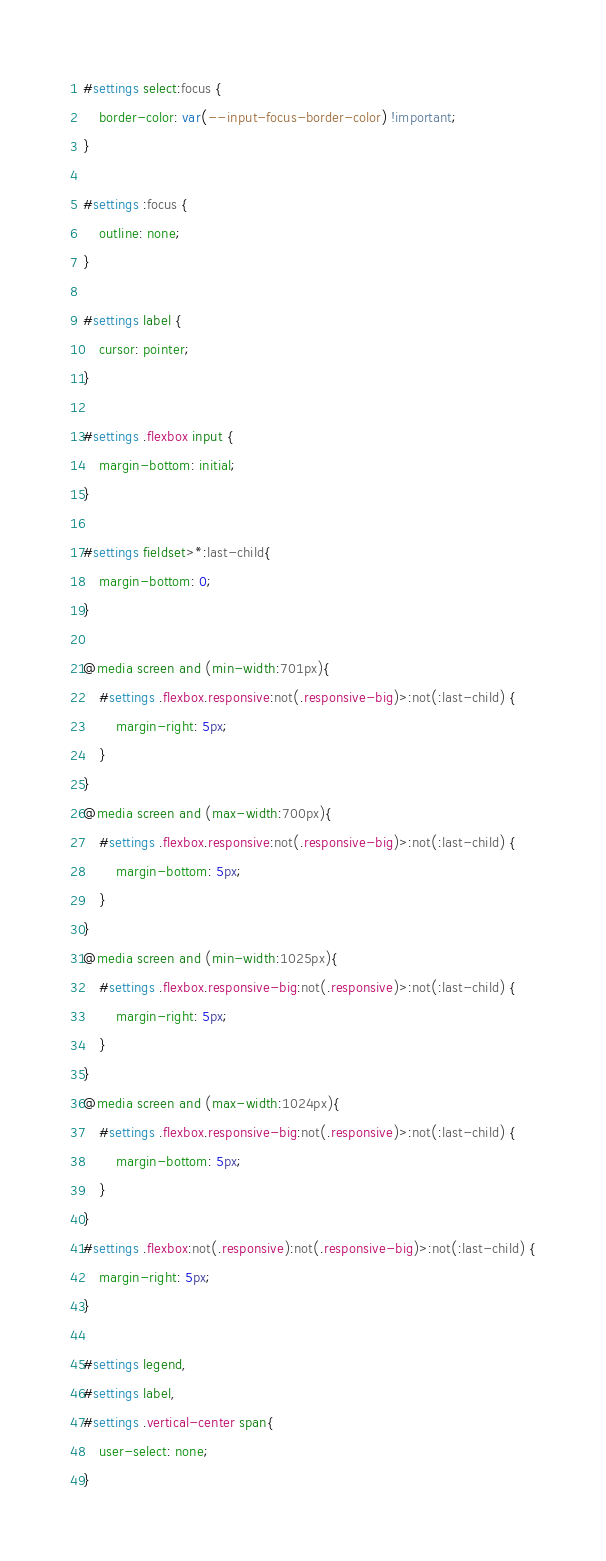Convert code to text. <code><loc_0><loc_0><loc_500><loc_500><_CSS_>#settings select:focus {
    border-color: var(--input-focus-border-color) !important;
}

#settings :focus {
    outline: none;
}

#settings label {
    cursor: pointer;
}

#settings .flexbox input {
    margin-bottom: initial;
}

#settings fieldset>*:last-child{
    margin-bottom: 0;
}

@media screen and (min-width:701px){
    #settings .flexbox.responsive:not(.responsive-big)>:not(:last-child) {
        margin-right: 5px;
    }
}
@media screen and (max-width:700px){
    #settings .flexbox.responsive:not(.responsive-big)>:not(:last-child) {
        margin-bottom: 5px;
    }
}
@media screen and (min-width:1025px){
    #settings .flexbox.responsive-big:not(.responsive)>:not(:last-child) {
        margin-right: 5px;
    }
}
@media screen and (max-width:1024px){
    #settings .flexbox.responsive-big:not(.responsive)>:not(:last-child) {
        margin-bottom: 5px;
    }
}
#settings .flexbox:not(.responsive):not(.responsive-big)>:not(:last-child) {
    margin-right: 5px;
}

#settings legend,
#settings label,
#settings .vertical-center span{
    user-select: none;
}
</code> 